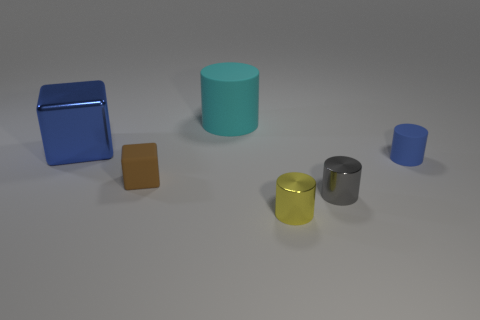What is the size of the cyan matte object?
Your answer should be very brief. Large. Is the number of tiny blue matte cylinders on the left side of the big cyan rubber cylinder less than the number of big yellow cubes?
Ensure brevity in your answer.  No. Is the small yellow cylinder made of the same material as the block behind the tiny blue matte object?
Provide a succinct answer. Yes. There is a matte thing that is on the left side of the large thing that is right of the blue metallic object; are there any matte things right of it?
Make the answer very short. Yes. Are there any other things that are the same size as the cyan cylinder?
Your answer should be very brief. Yes. What color is the other cylinder that is made of the same material as the tiny blue cylinder?
Ensure brevity in your answer.  Cyan. What size is the rubber object that is left of the gray metallic cylinder and to the right of the tiny matte cube?
Your answer should be compact. Large. Is the number of gray cylinders behind the small brown matte block less than the number of blue cubes that are behind the cyan matte cylinder?
Give a very brief answer. No. Are the blue cube left of the tiny yellow cylinder and the tiny thing that is in front of the gray metal cylinder made of the same material?
Keep it short and to the point. Yes. There is a object that is the same color as the big shiny block; what is its material?
Keep it short and to the point. Rubber. 